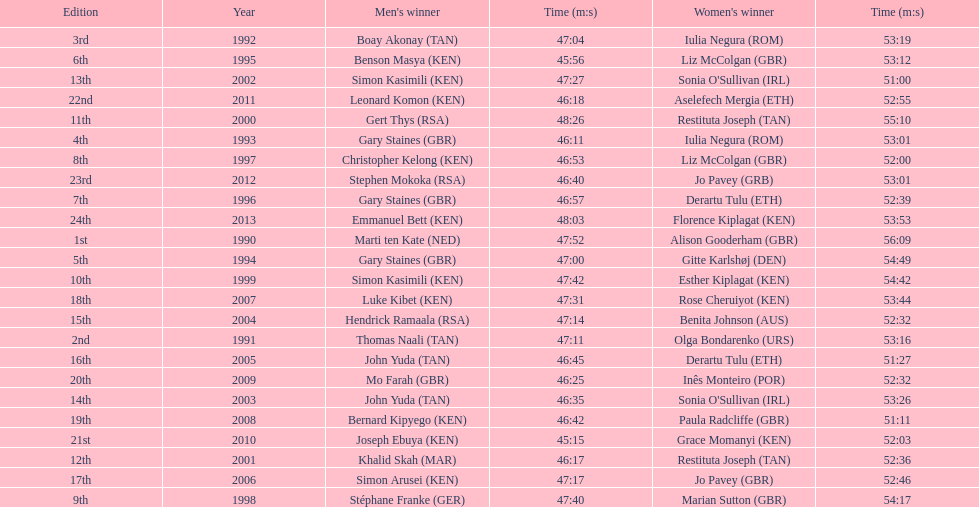What place did sonia o'sullivan finish in 2003? 14th. How long did it take her to finish? 53:26. 